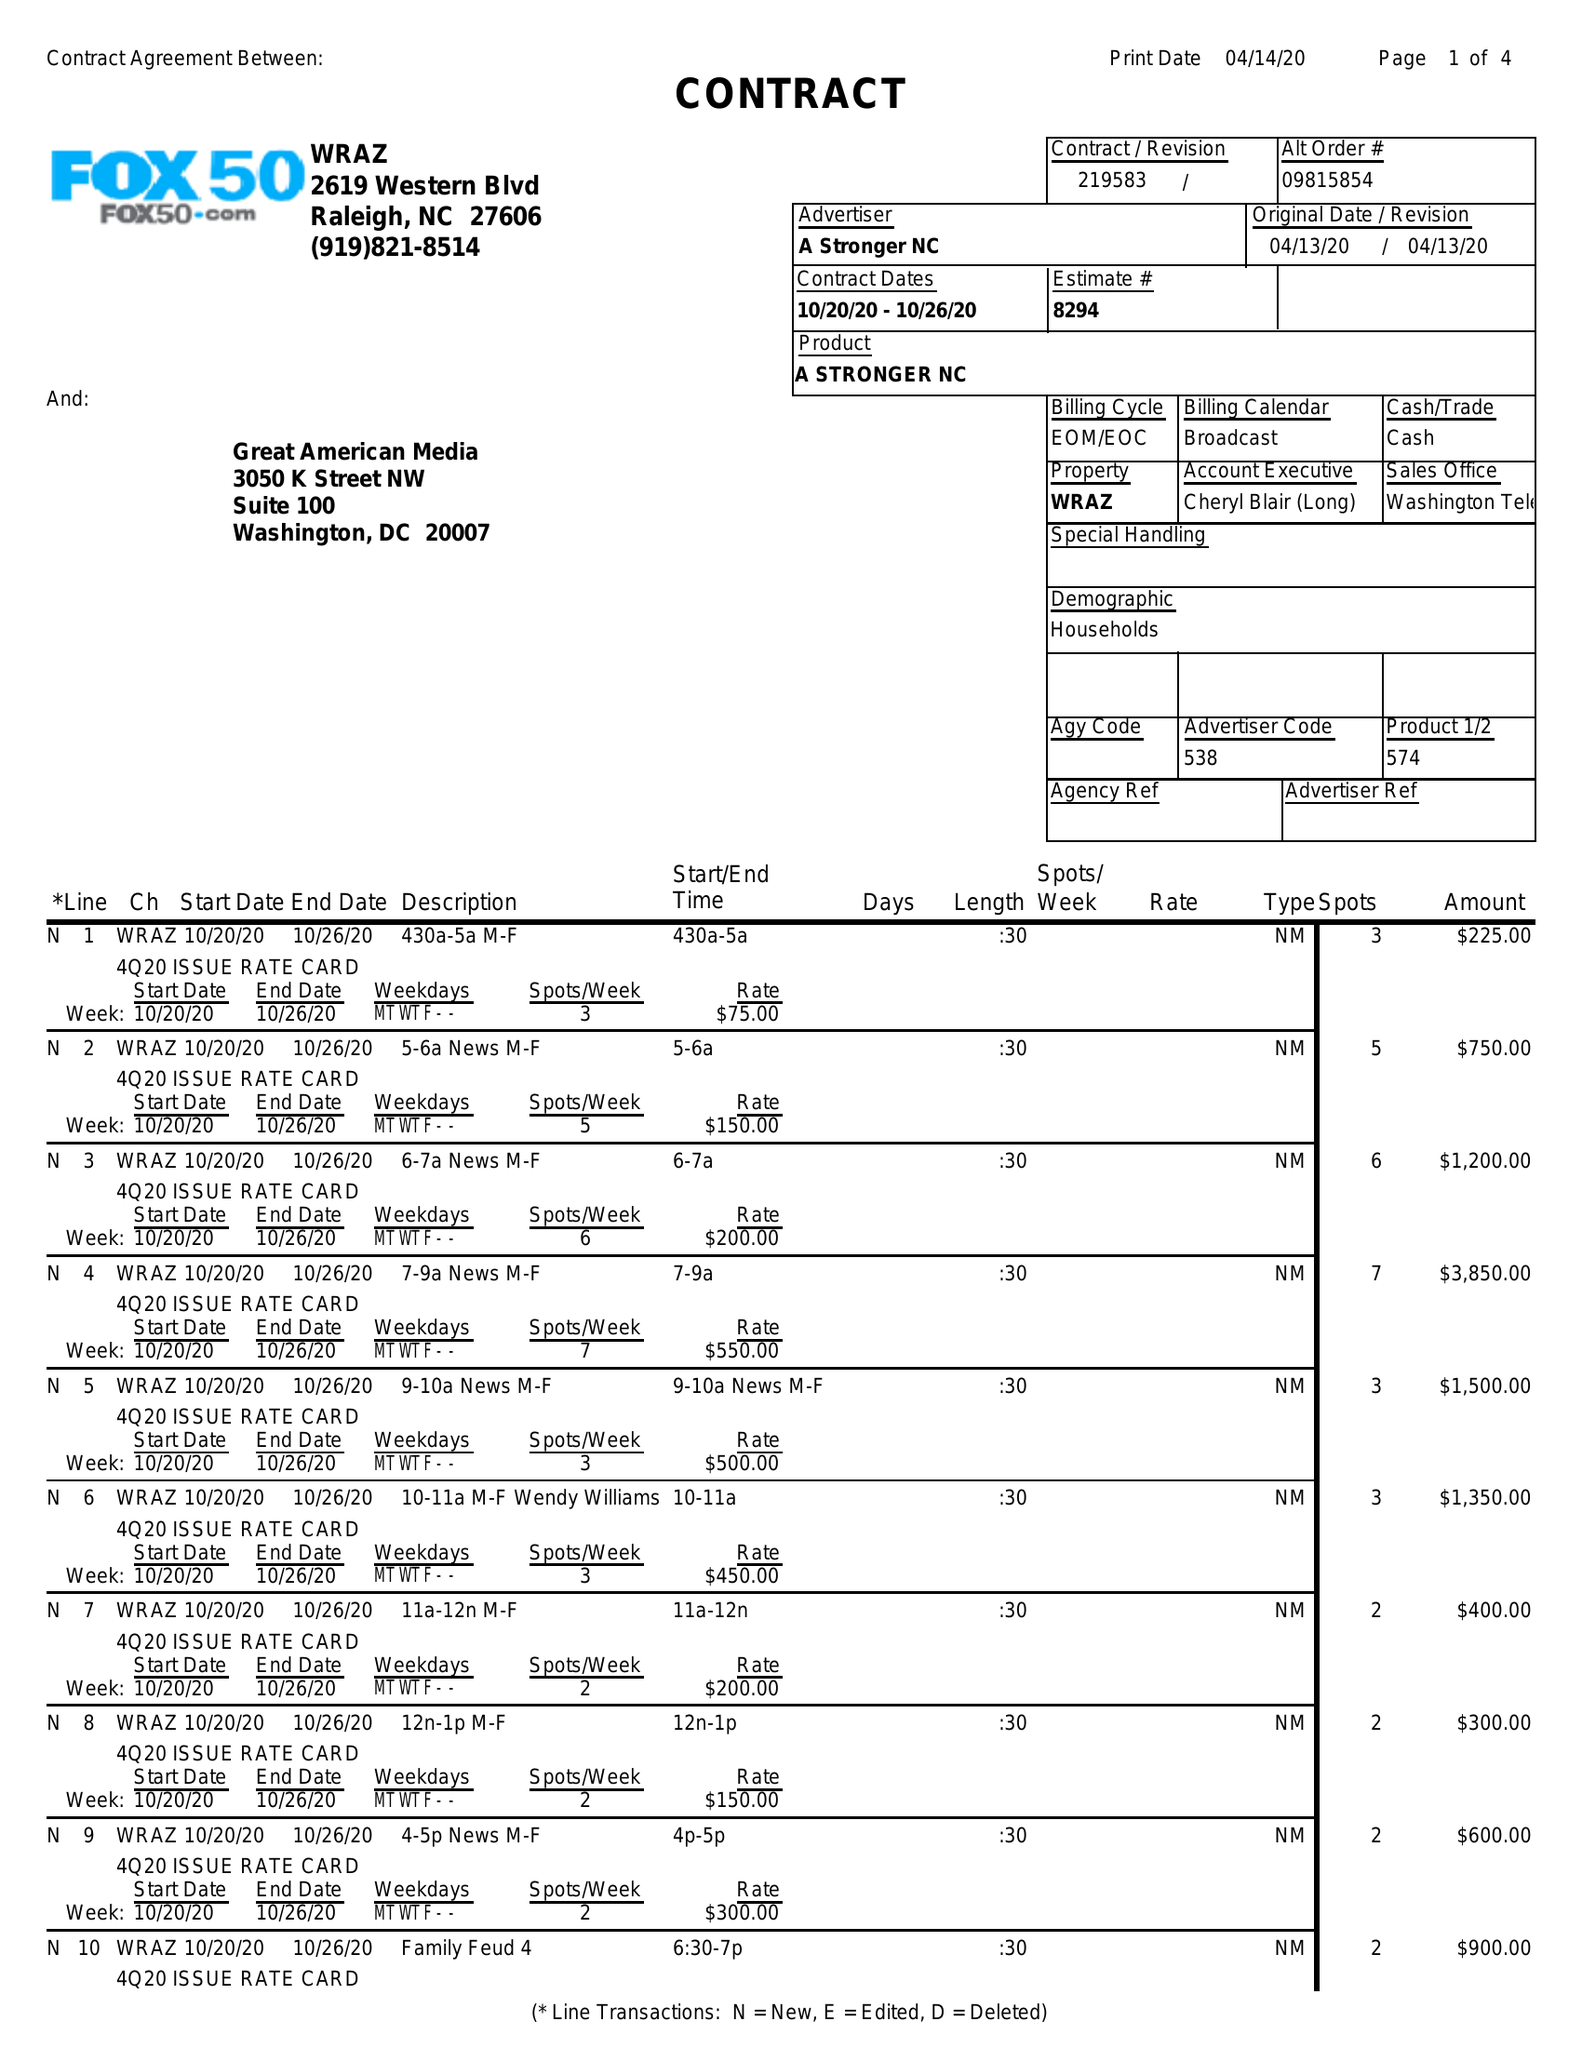What is the value for the advertiser?
Answer the question using a single word or phrase. A STRONGER NC 